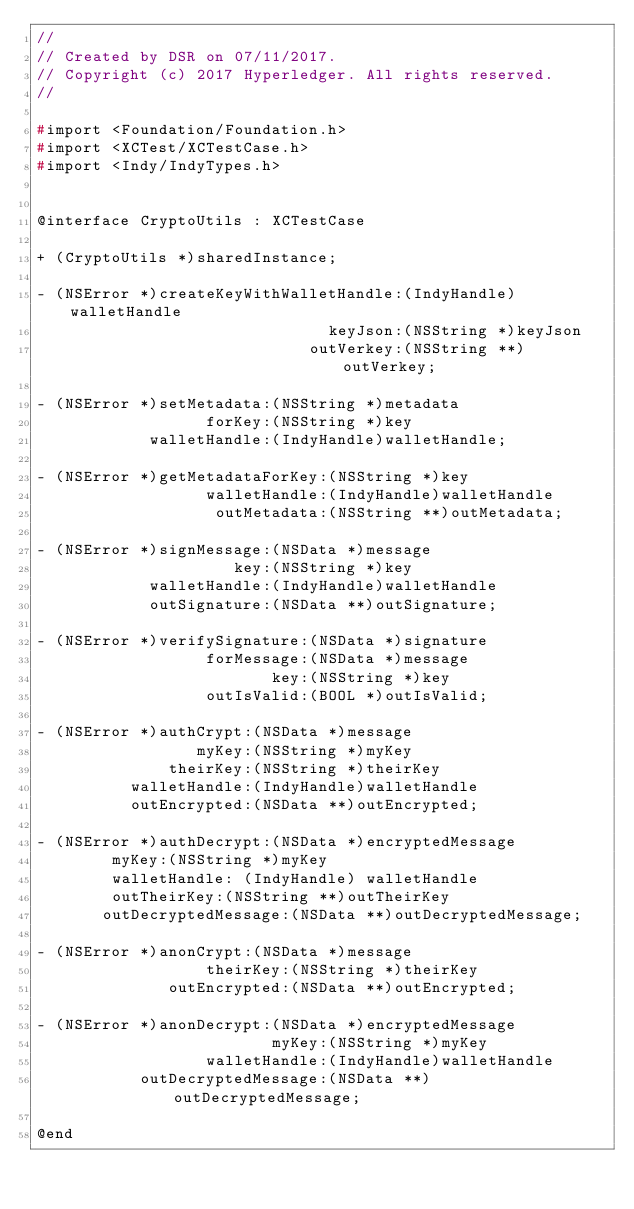Convert code to text. <code><loc_0><loc_0><loc_500><loc_500><_C_>//
// Created by DSR on 07/11/2017.
// Copyright (c) 2017 Hyperledger. All rights reserved.
//

#import <Foundation/Foundation.h>
#import <XCTest/XCTestCase.h>
#import <Indy/IndyTypes.h>


@interface CryptoUtils : XCTestCase

+ (CryptoUtils *)sharedInstance;

- (NSError *)createKeyWithWalletHandle:(IndyHandle)walletHandle
                               keyJson:(NSString *)keyJson
                             outVerkey:(NSString **)outVerkey;

- (NSError *)setMetadata:(NSString *)metadata
                  forKey:(NSString *)key
            walletHandle:(IndyHandle)walletHandle;

- (NSError *)getMetadataForKey:(NSString *)key
                  walletHandle:(IndyHandle)walletHandle
                   outMetadata:(NSString **)outMetadata;

- (NSError *)signMessage:(NSData *)message
                     key:(NSString *)key
            walletHandle:(IndyHandle)walletHandle
            outSignature:(NSData **)outSignature;

- (NSError *)verifySignature:(NSData *)signature
                  forMessage:(NSData *)message
                         key:(NSString *)key
                  outIsValid:(BOOL *)outIsValid;

- (NSError *)authCrypt:(NSData *)message
                 myKey:(NSString *)myKey
              theirKey:(NSString *)theirKey
          walletHandle:(IndyHandle)walletHandle
          outEncrypted:(NSData **)outEncrypted;

- (NSError *)authDecrypt:(NSData *)encryptedMessage
        myKey:(NSString *)myKey
        walletHandle: (IndyHandle) walletHandle
        outTheirKey:(NSString **)outTheirKey
       outDecryptedMessage:(NSData **)outDecryptedMessage;

- (NSError *)anonCrypt:(NSData *)message
                  theirKey:(NSString *)theirKey
              outEncrypted:(NSData **)outEncrypted;

- (NSError *)anonDecrypt:(NSData *)encryptedMessage
                         myKey:(NSString *)myKey
                  walletHandle:(IndyHandle)walletHandle
           outDecryptedMessage:(NSData **)outDecryptedMessage;

@end</code> 